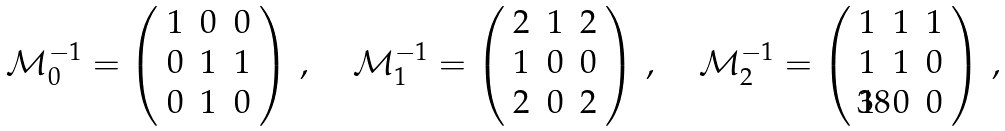Convert formula to latex. <formula><loc_0><loc_0><loc_500><loc_500>\mathcal { M } _ { 0 } ^ { - 1 } = \left ( \begin{array} { c c c } 1 & 0 & 0 \\ 0 & 1 & 1 \\ 0 & 1 & 0 \end{array} \right ) \, , \quad \, \mathcal { M } _ { 1 } ^ { - 1 } = \left ( \begin{array} { c c c } 2 & 1 & 2 \\ 1 & 0 & 0 \\ 2 & 0 & 2 \end{array} \right ) \, , \quad \, \mathcal { M } _ { 2 } ^ { - 1 } = \left ( \begin{array} { c c c } 1 & 1 & 1 \\ 1 & 1 & 0 \\ 1 & 0 & 0 \end{array} \right ) \, ,</formula> 